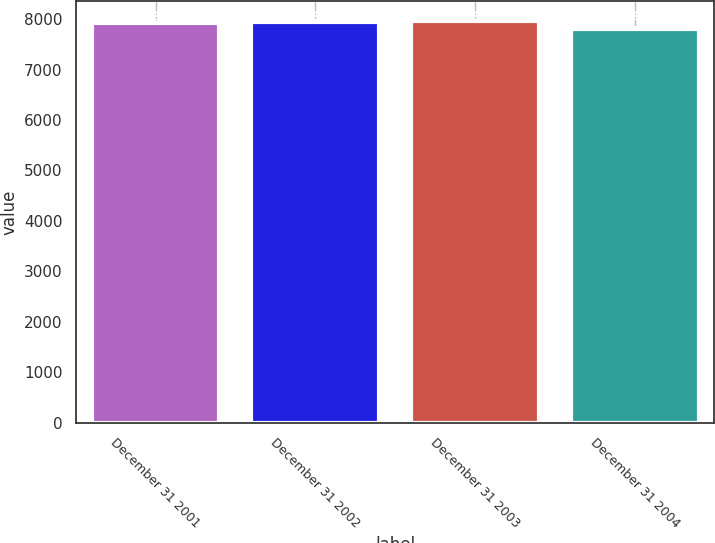Convert chart to OTSL. <chart><loc_0><loc_0><loc_500><loc_500><bar_chart><fcel>December 31 2001<fcel>December 31 2002<fcel>December 31 2003<fcel>December 31 2004<nl><fcel>7929<fcel>7942.6<fcel>7956.2<fcel>7806<nl></chart> 